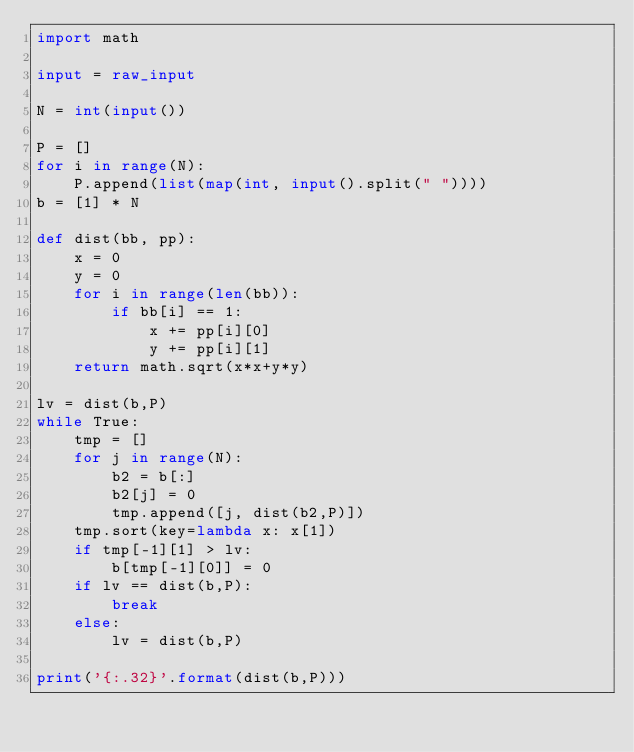<code> <loc_0><loc_0><loc_500><loc_500><_Python_>import math

input = raw_input

N = int(input())

P = []
for i in range(N):
    P.append(list(map(int, input().split(" "))))
b = [1] * N

def dist(bb, pp):
    x = 0
    y = 0
    for i in range(len(bb)):
        if bb[i] == 1:
            x += pp[i][0]
            y += pp[i][1]
    return math.sqrt(x*x+y*y)

lv = dist(b,P)
while True:
    tmp = []
    for j in range(N):
        b2 = b[:]
        b2[j] = 0
        tmp.append([j, dist(b2,P)])
    tmp.sort(key=lambda x: x[1])
    if tmp[-1][1] > lv:
        b[tmp[-1][0]] = 0
    if lv == dist(b,P):
        break
    else:
        lv = dist(b,P)

print('{:.32}'.format(dist(b,P)))
</code> 